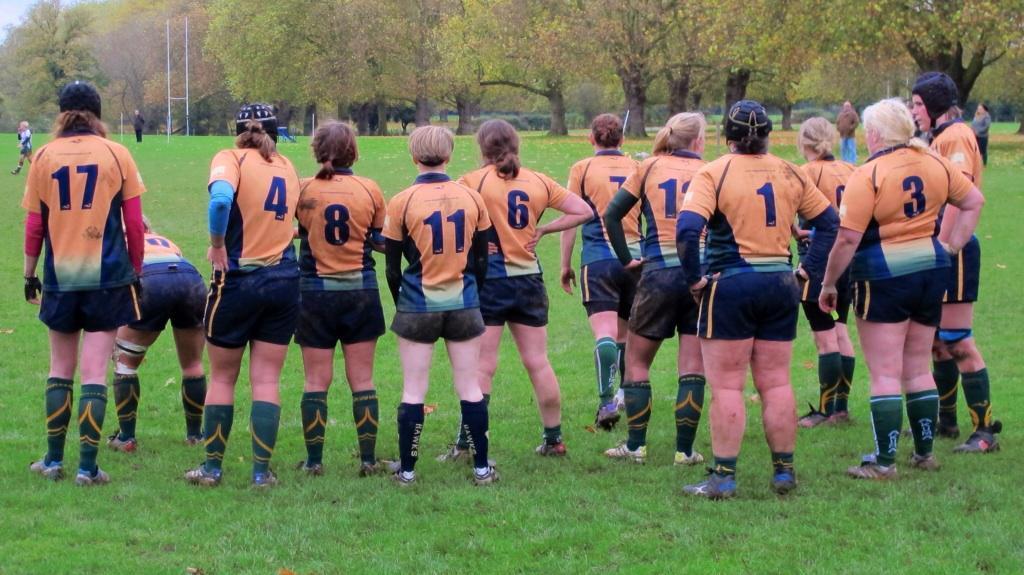Describe this image in one or two sentences. In this image we can see some persons wearing similar dress and shoes and there are different jersey numbers on their T-shirts and at the background of the image there are some persons standing here and there, there are some trees. 